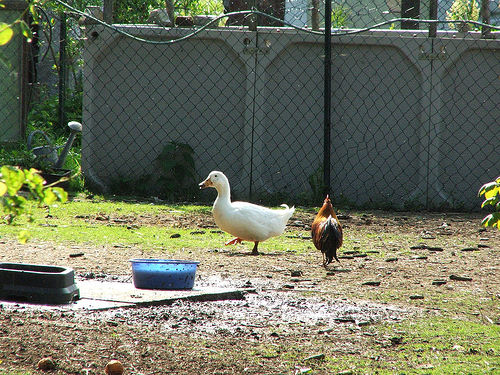<image>
Can you confirm if the goose is next to the rooster? Yes. The goose is positioned adjacent to the rooster, located nearby in the same general area. 